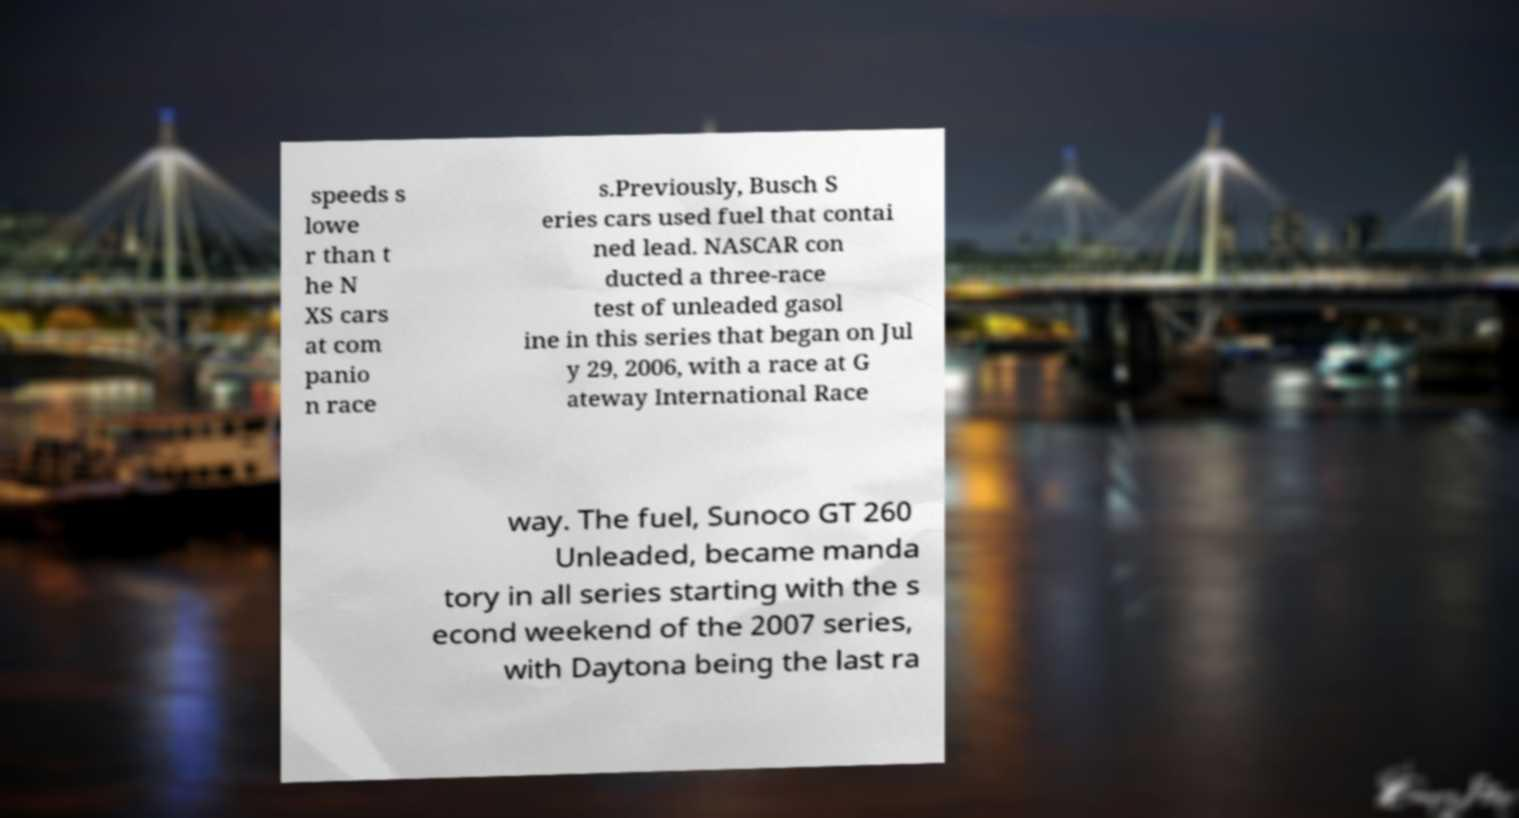Can you accurately transcribe the text from the provided image for me? speeds s lowe r than t he N XS cars at com panio n race s.Previously, Busch S eries cars used fuel that contai ned lead. NASCAR con ducted a three-race test of unleaded gasol ine in this series that began on Jul y 29, 2006, with a race at G ateway International Race way. The fuel, Sunoco GT 260 Unleaded, became manda tory in all series starting with the s econd weekend of the 2007 series, with Daytona being the last ra 